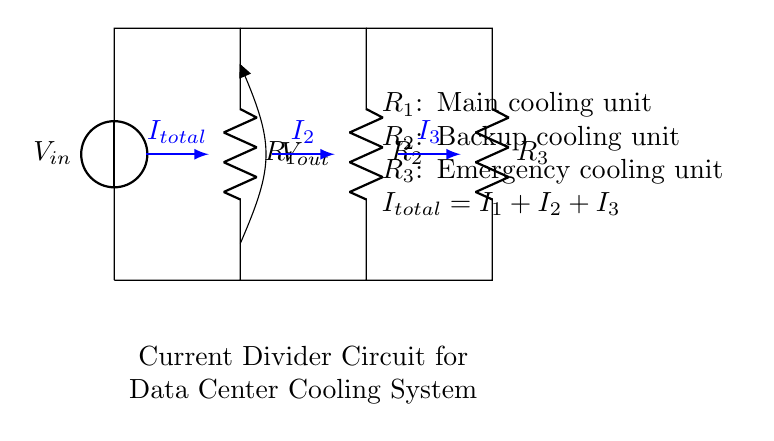What is the value of R1 in this circuit? The circuit diagram shows that R1, representing the main cooling unit, is labeled but does not provide a numerical value directly. Therefore, we cannot determine the exact resistance value from the diagram alone.
Answer: Not specified What type of circuit is this? The circuit is a parallel circuit, characterized by multiple branches where the current can divide among the resistors, resulting in the voltage across each resistor remaining equal.
Answer: Parallel What is the total current in the circuit? The total current, denoted as I_total, is represented in the diagram as the sum of the individual currents through the resistors, I1, I2, and I3. Since specific current values are not provided, it is only labeled in a generalized form.
Answer: I1 + I2 + I3 What would happen if R3 is removed from the circuit? Removing R3, the emergency cooling unit, would mean the current would only flow through R1 and R2. Hence, the total current would be redistributed only between them, potentially increasing current through those resistors depending on their resistance values.
Answer: Increased current through R1 and R2 What does I2 represent in this circuit? I2 signifies the current flowing through R2, the backup cooling unit, according to the representation in the circuit. This is an essential measurement for evaluating how well the backup unit is functioning.
Answer: Current through the backup cooling unit 